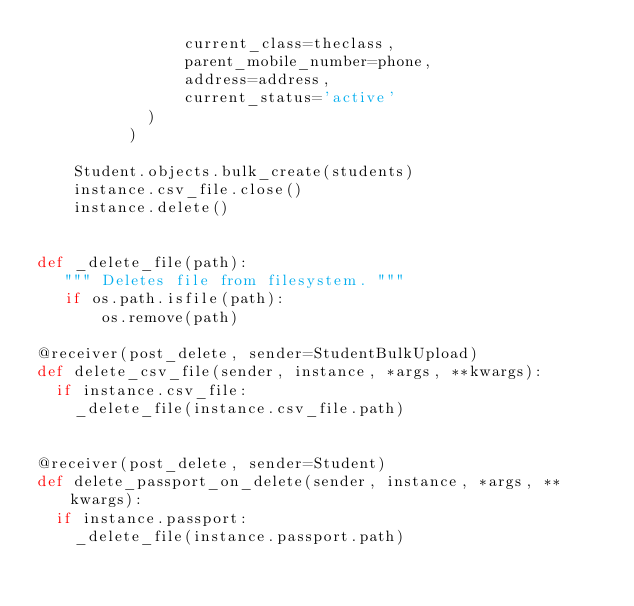Convert code to text. <code><loc_0><loc_0><loc_500><loc_500><_Python_>                current_class=theclass,
                parent_mobile_number=phone,
                address=address,
                current_status='active'
            )
          )

    Student.objects.bulk_create(students)
    instance.csv_file.close()
    instance.delete()


def _delete_file(path):
   """ Deletes file from filesystem. """
   if os.path.isfile(path):
       os.remove(path)

@receiver(post_delete, sender=StudentBulkUpload)
def delete_csv_file(sender, instance, *args, **kwargs):
  if instance.csv_file:
    _delete_file(instance.csv_file.path)


@receiver(post_delete, sender=Student)
def delete_passport_on_delete(sender, instance, *args, **kwargs):
  if instance.passport:
    _delete_file(instance.passport.path)
</code> 